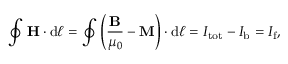<formula> <loc_0><loc_0><loc_500><loc_500>\oint H \cdot d { \ell } = \oint \left ( { \frac { B } { \mu _ { 0 } } } - M \right ) \cdot d { \ell } = I _ { t o t } - I _ { b } = I _ { f } ,</formula> 